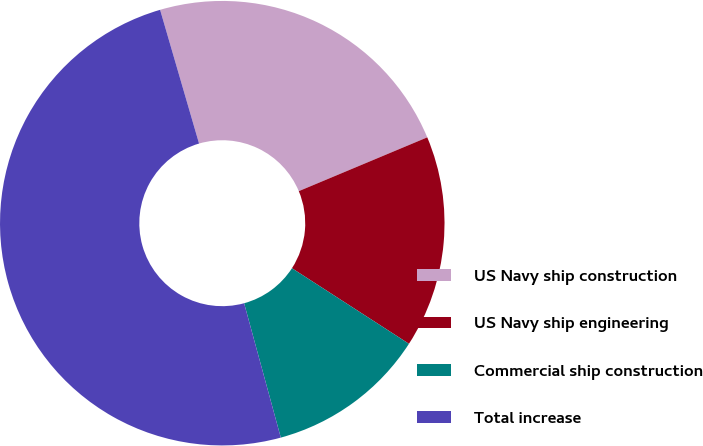<chart> <loc_0><loc_0><loc_500><loc_500><pie_chart><fcel>US Navy ship construction<fcel>US Navy ship engineering<fcel>Commercial ship construction<fcel>Total increase<nl><fcel>23.2%<fcel>15.44%<fcel>11.63%<fcel>49.73%<nl></chart> 